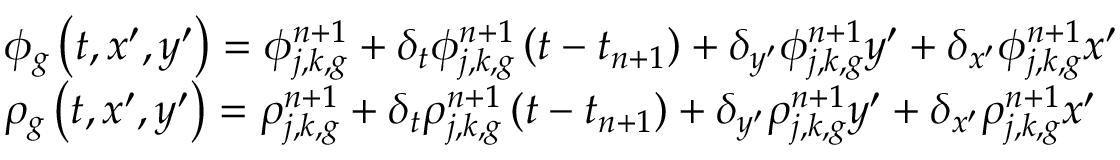<formula> <loc_0><loc_0><loc_500><loc_500>\begin{array} { l } { { \phi _ { g } \left ( t , x ^ { \prime } , y ^ { \prime } \right ) = \phi _ { j , k , g } ^ { n + 1 } + \delta _ { t } \phi _ { j , k , g } ^ { n + 1 } \left ( t - t _ { n + 1 } \right ) + \delta _ { y ^ { \prime } } \phi _ { j , k , g } ^ { n + 1 } y ^ { \prime } + \delta _ { x ^ { \prime } } \phi _ { j , k , g } ^ { n + 1 } x ^ { \prime } } } \\ { { \rho _ { g } \left ( t , x ^ { \prime } , y ^ { \prime } \right ) = \rho _ { j , k , g } ^ { n + 1 } + \delta _ { t } \rho _ { j , k , g } ^ { n + 1 } \left ( t - t _ { n + 1 } \right ) + \delta _ { y ^ { \prime } } \rho _ { j , k , g } ^ { n + 1 } y ^ { \prime } + \delta _ { x ^ { \prime } } \rho _ { j , k , g } ^ { n + 1 } x ^ { \prime } } } \end{array}</formula> 